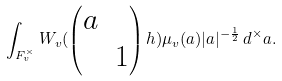<formula> <loc_0><loc_0><loc_500><loc_500>\int _ { F _ { v } ^ { \times } } W _ { v } ( \begin{pmatrix} a \\ & 1 \end{pmatrix} h ) \mu _ { v } ( a ) | a | ^ { - \frac { 1 } { 2 } } \, d ^ { \times } a .</formula> 